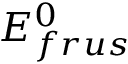Convert formula to latex. <formula><loc_0><loc_0><loc_500><loc_500>E _ { f r u s } ^ { 0 }</formula> 